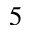<formula> <loc_0><loc_0><loc_500><loc_500>^ { 5 }</formula> 